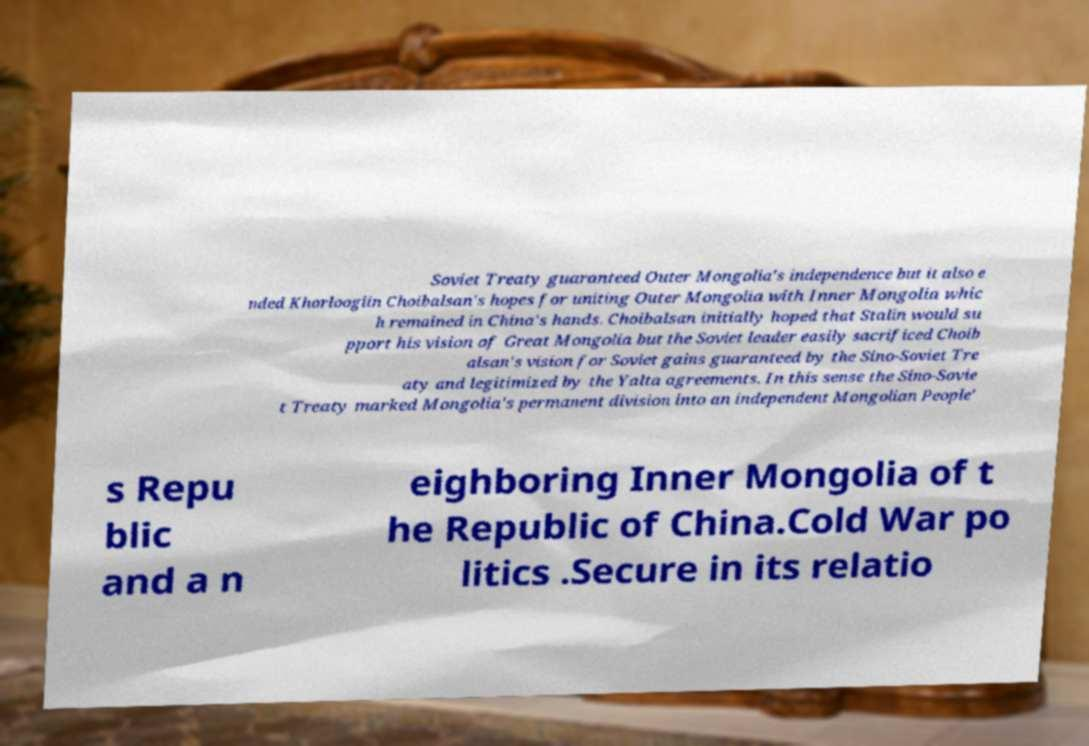Please identify and transcribe the text found in this image. Soviet Treaty guaranteed Outer Mongolia's independence but it also e nded Khorloogiin Choibalsan's hopes for uniting Outer Mongolia with Inner Mongolia whic h remained in China's hands. Choibalsan initially hoped that Stalin would su pport his vision of Great Mongolia but the Soviet leader easily sacrificed Choib alsan's vision for Soviet gains guaranteed by the Sino-Soviet Tre aty and legitimized by the Yalta agreements. In this sense the Sino-Sovie t Treaty marked Mongolia's permanent division into an independent Mongolian People' s Repu blic and a n eighboring Inner Mongolia of t he Republic of China.Cold War po litics .Secure in its relatio 